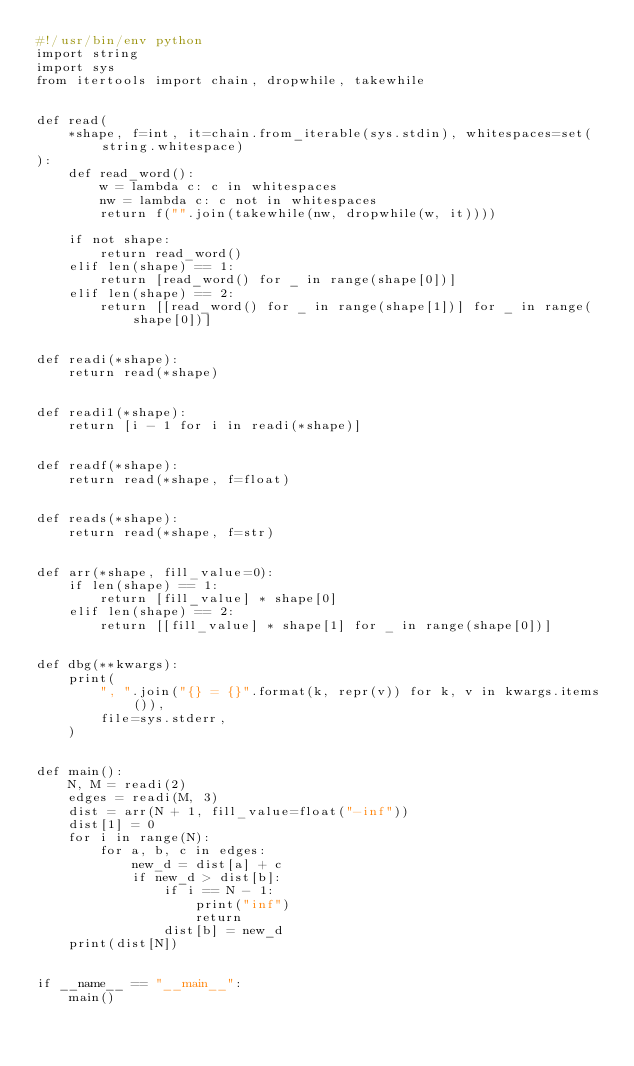<code> <loc_0><loc_0><loc_500><loc_500><_Python_>#!/usr/bin/env python
import string
import sys
from itertools import chain, dropwhile, takewhile


def read(
    *shape, f=int, it=chain.from_iterable(sys.stdin), whitespaces=set(string.whitespace)
):
    def read_word():
        w = lambda c: c in whitespaces
        nw = lambda c: c not in whitespaces
        return f("".join(takewhile(nw, dropwhile(w, it))))

    if not shape:
        return read_word()
    elif len(shape) == 1:
        return [read_word() for _ in range(shape[0])]
    elif len(shape) == 2:
        return [[read_word() for _ in range(shape[1])] for _ in range(shape[0])]


def readi(*shape):
    return read(*shape)


def readi1(*shape):
    return [i - 1 for i in readi(*shape)]


def readf(*shape):
    return read(*shape, f=float)


def reads(*shape):
    return read(*shape, f=str)


def arr(*shape, fill_value=0):
    if len(shape) == 1:
        return [fill_value] * shape[0]
    elif len(shape) == 2:
        return [[fill_value] * shape[1] for _ in range(shape[0])]


def dbg(**kwargs):
    print(
        ", ".join("{} = {}".format(k, repr(v)) for k, v in kwargs.items()),
        file=sys.stderr,
    )


def main():
    N, M = readi(2)
    edges = readi(M, 3)
    dist = arr(N + 1, fill_value=float("-inf"))
    dist[1] = 0
    for i in range(N):
        for a, b, c in edges:
            new_d = dist[a] + c
            if new_d > dist[b]:
                if i == N - 1:
                    print("inf")
                    return
                dist[b] = new_d
    print(dist[N])


if __name__ == "__main__":
    main()
</code> 